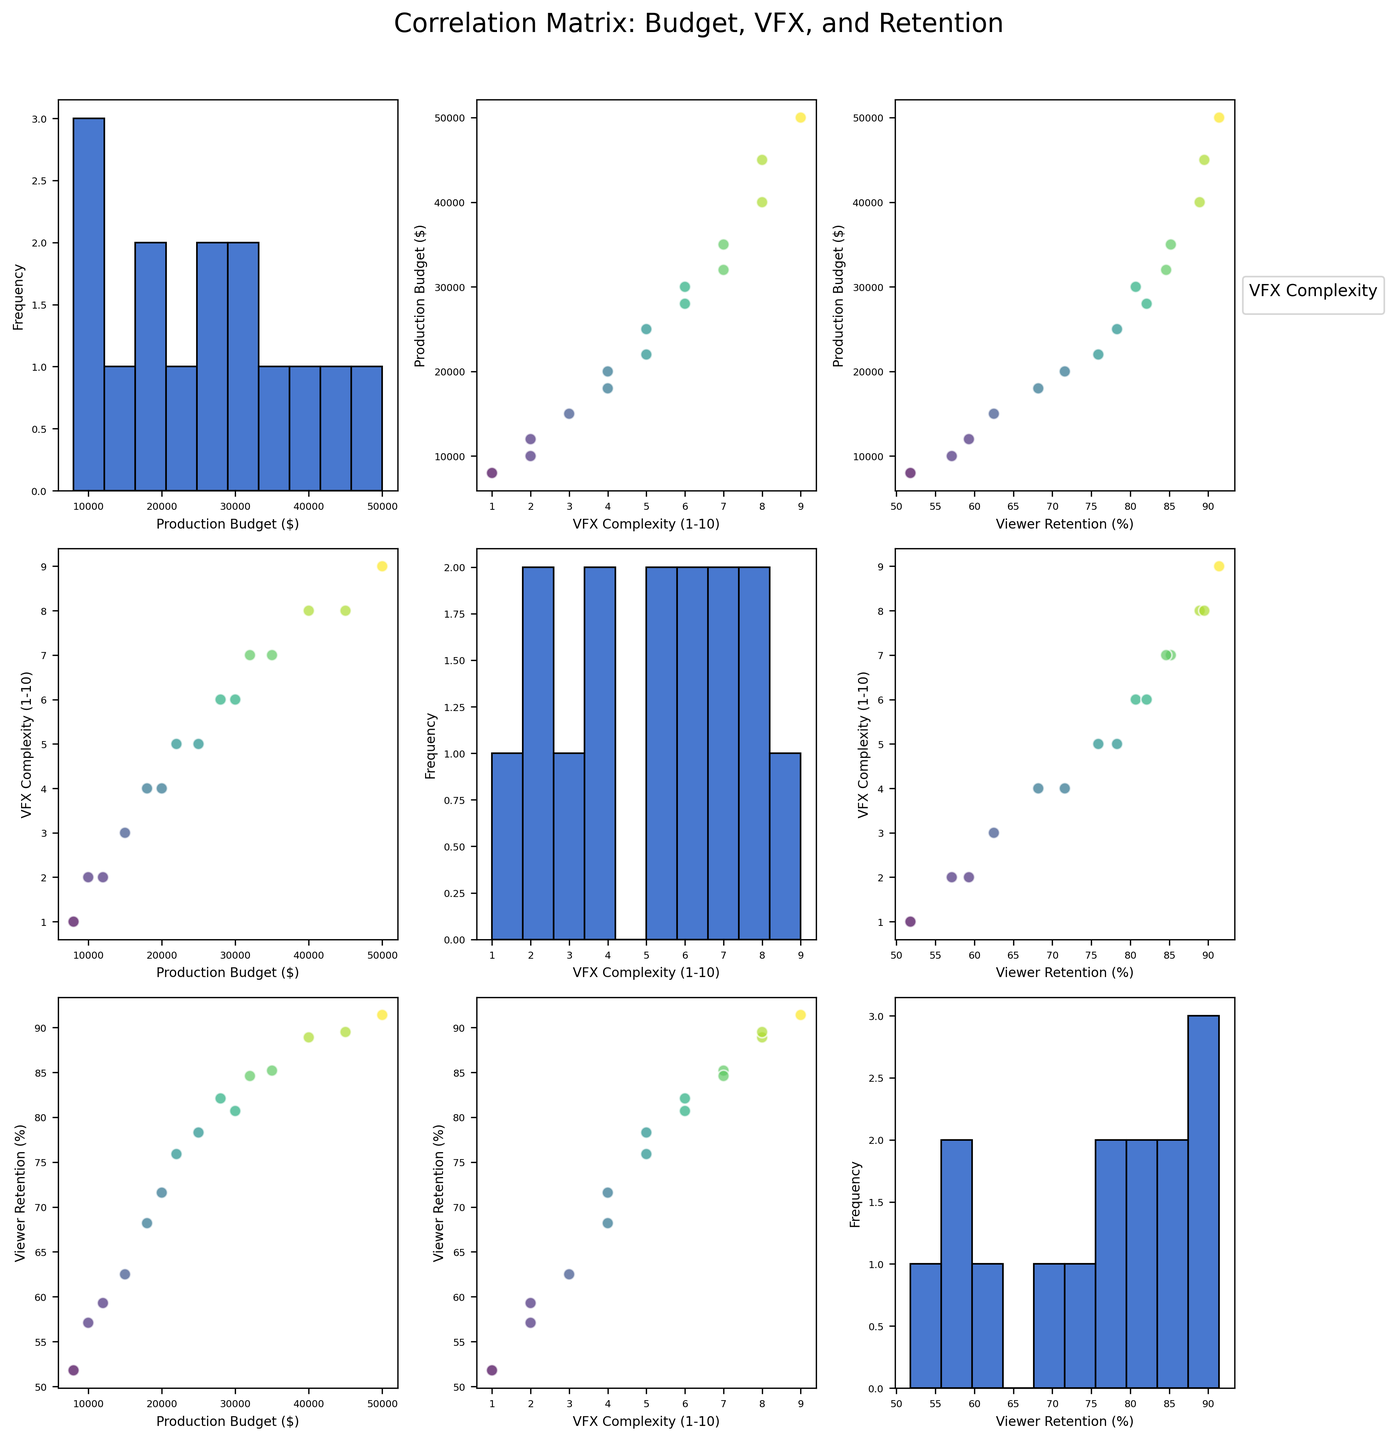What's the title of the figure? The title of the figure is displayed at the top, centrally positioned, and typically uses a slightly larger font size. It summarizes what the scatterplot matrix is about.
Answer: Correlation Matrix: Budget, VFX, and Retention How many data points are represented in each scatter plot? The scatter plot matrix includes plots for several variables and each of these plots represents all data points. Each brand corresponds to a data point. Counting the number of brands listed in the data gives us the total.
Answer: 15 Which variable shows the greatest spread in its histogram? To determine the variable with the greatest spread, we observe the histograms on the diagonal. The histogram with the widest range of bin values indicates the variable with the greatest spread.
Answer: Production Budget Is there a positive correlation between production budget and viewer retention? We need to look at the scatter plot where 'Production Budget ($)' is on one axis and 'Viewer Retention (%)' is on the other. A positive correlation will show as an upward trend from left to right.
Answer: Yes Which brand has the highest viewer retention rate? We identify the highest point in the 'Viewer Retention (%)' histogram and correlate it to the respective brand in the data list.
Answer: Apple Which scatter plot shows a weak correlation between its variables? We compare scatter plots and identify which plot has points scattered without any discernible pattern or trend.
Answer: VFX Complexity vs. Production Budget How does viewer retention rate correlate with VFX complexity? We compare the scatter plot with 'Viewer Retention (%)' on one axis and 'VFX Complexity (1-10)' on the other. If points trend upwards, the correlation is positive; if downwards, negative.
Answer: Positive correlation What is the average production budget for all brands? Add all production budget values and divide by the number of data points. (15000+25000+10000+35000+20000+50000+30000+40000+18000+22000+12000+28000+45000+8000+32000) / 15 = 400000 / 15 = 26666.67
Answer: $26,666.67 Between which two variables is the strongest apparent correlation? By visual inspection of the scatter plot matrix, we identify the pair of variables where data points most consistently follow a linear trend.
Answer: VFX Complexity and Viewer Retention How are the colors in the scatter plots determined? The scatter plots use colors to represent 'VFX Complexity (1-10)' with a gradient of shades. Darker shades tend to indicate higher complexity values.
Answer: By VFX Complexity 